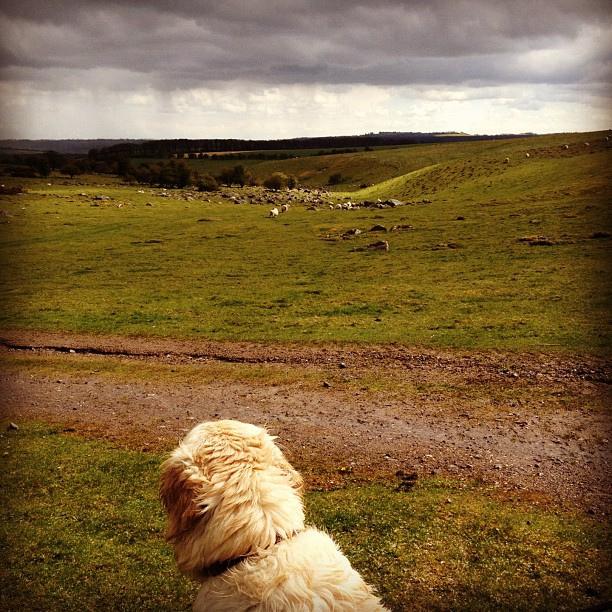What type of animal is in this photo?
Answer briefly. Dog. What color is the dog?
Be succinct. White. What animals are those?
Short answer required. Dog. What color is the dogs' fur?
Short answer required. White. What type of animals are these?
Answer briefly. Dog. Is the dog hungry?
Answer briefly. No. Are there trees in the valley?
Answer briefly. Yes. Is it going to rain later?
Quick response, please. Yes. What kind of animal is that?
Be succinct. Dog. 